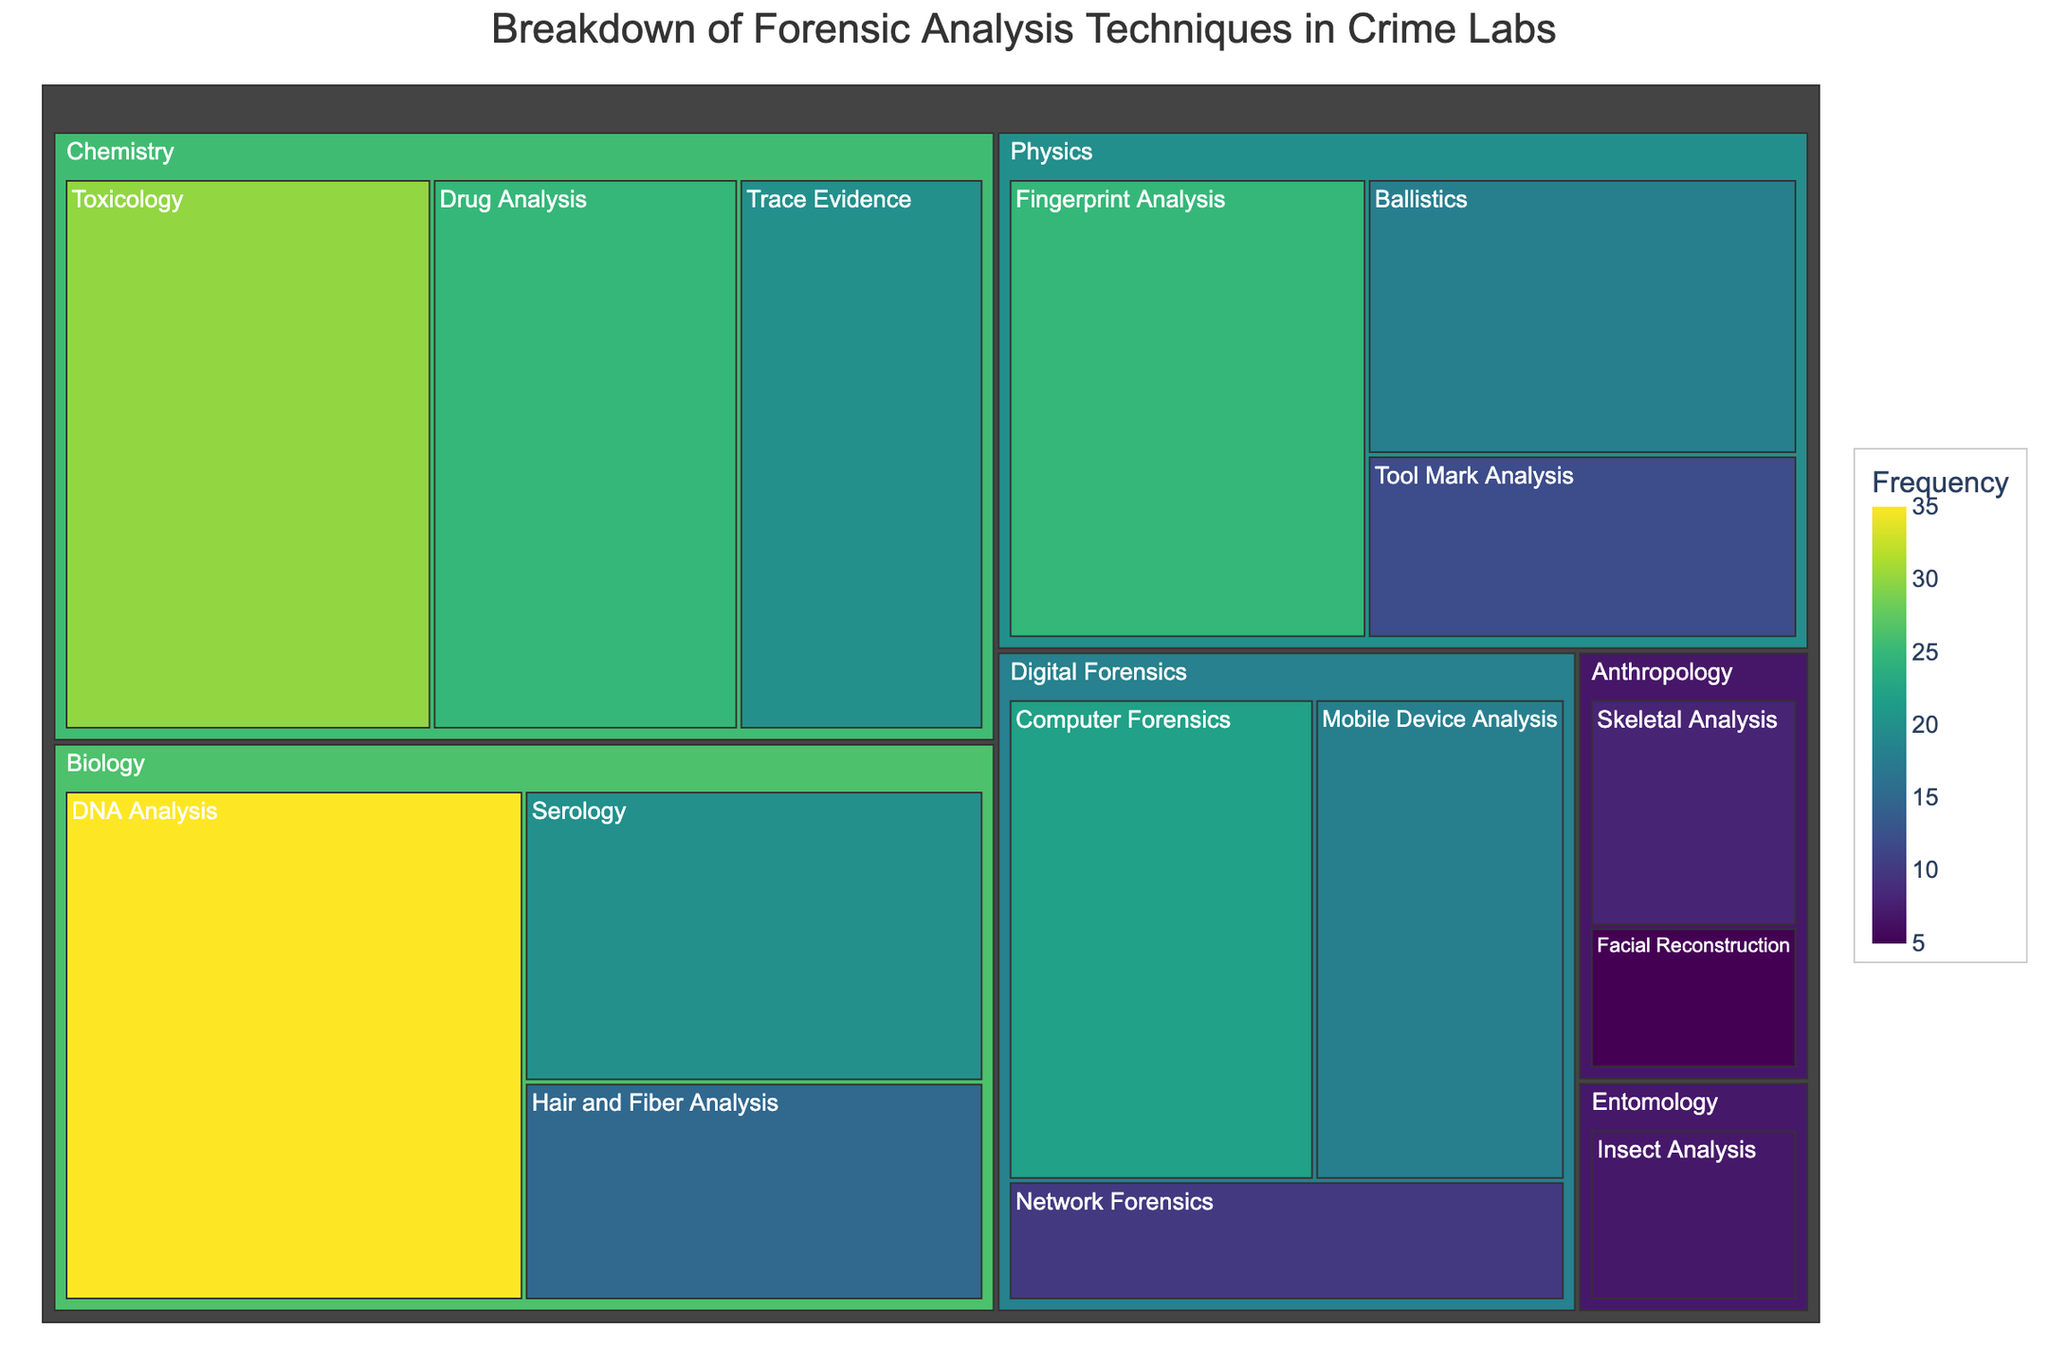What's the title of the figure? The title is usually displayed at the top of the figure. Checking the title will give us the main topic of the visualized data.
Answer: Breakdown of Forensic Analysis Techniques in Crime Labs Which scientific discipline has the highest overall value? By observing the size of the sections in the treemap, we can identify the discipline with the largest combined area, which indicates the highest overall value.
Answer: Biology How many subcategories are there under Chemistry? Look for the Chemistry category and count the number of subcategories within it.
Answer: 3 What is the value difference between DNA Analysis and Serology? Locate DNA Analysis and Serology within Biology, then subtract the value of Serology from DNA Analysis (35 - 20).
Answer: 15 Which subcategory in Digital Forensics has the lowest value? Check the size of the subcategories under Digital Forensics and identify the one with the smallest area.
Answer: Network Forensics What is the average value of subcategories in Biology? Sum the values of all subcategories in Biology (35 + 20 + 15) and divide by the number of subcategories (3).
Answer: 23.33 Which forensic technique has a value equal to the difference between the highest and lowest values in the list? Find the highest value (35) and the lowest value (5). Calculate the difference (35 - 5 = 30) and find the technique with this value.
Answer: Toxicology Compare the total values of Chemistry and Physics. Which is greater and by how much? Add the values of subcategories in Chemistry (30 + 25 + 20) and Physics (18 + 12 + 25). Compare the sums (75 vs 55).
Answer: Chemistry by 20 List the subcategories in Anthropology and their values. Look for the Anthropology category and note the subcategories along with their values.
Answer: Skeletal Analysis: 8, Facial Reconstruction: 5 What percentage of the total value does Fingerprint Analysis account for? Add all values to find the total (35 + 20 + 15 + 30 + 25 + 20 + 18 + 12 + 25 + 22 + 18 + 10 + 8 + 5 + 7 = 270). Divide Fingerprint Analysis value (25) by total and multiply by 100 to get the percentage.
Answer: 9.26% 